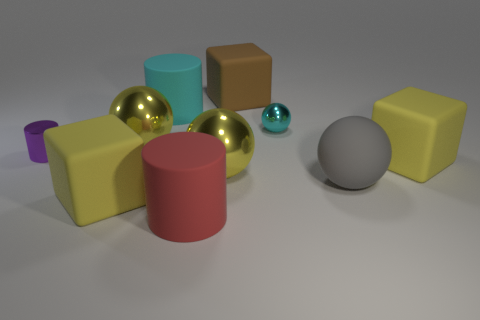Are there any other things that have the same color as the metal cylinder?
Offer a terse response. No. How many other objects are there of the same shape as the red rubber object?
Provide a short and direct response. 2. There is a cylinder that is both behind the big rubber ball and in front of the tiny cyan metallic object; what size is it?
Provide a short and direct response. Small. How many shiny things are tiny blue cylinders or big red things?
Provide a succinct answer. 0. There is a small thing that is to the right of the purple metallic object; is it the same shape as the big yellow metallic object that is behind the tiny purple shiny cylinder?
Provide a succinct answer. Yes. Is there a small cyan thing made of the same material as the red thing?
Offer a terse response. No. The small cylinder has what color?
Provide a short and direct response. Purple. There is a purple metal cylinder that is behind the red rubber cylinder; what is its size?
Provide a short and direct response. Small. How many big cylinders are the same color as the tiny metallic ball?
Provide a short and direct response. 1. Are there any purple cylinders to the left of the cube behind the tiny cylinder?
Provide a short and direct response. Yes. 